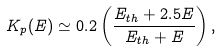Convert formula to latex. <formula><loc_0><loc_0><loc_500><loc_500>K _ { p } ( E ) \simeq 0 . 2 \left ( \frac { E _ { t h } + 2 . 5 E } { E _ { t h } + E } \right ) ,</formula> 